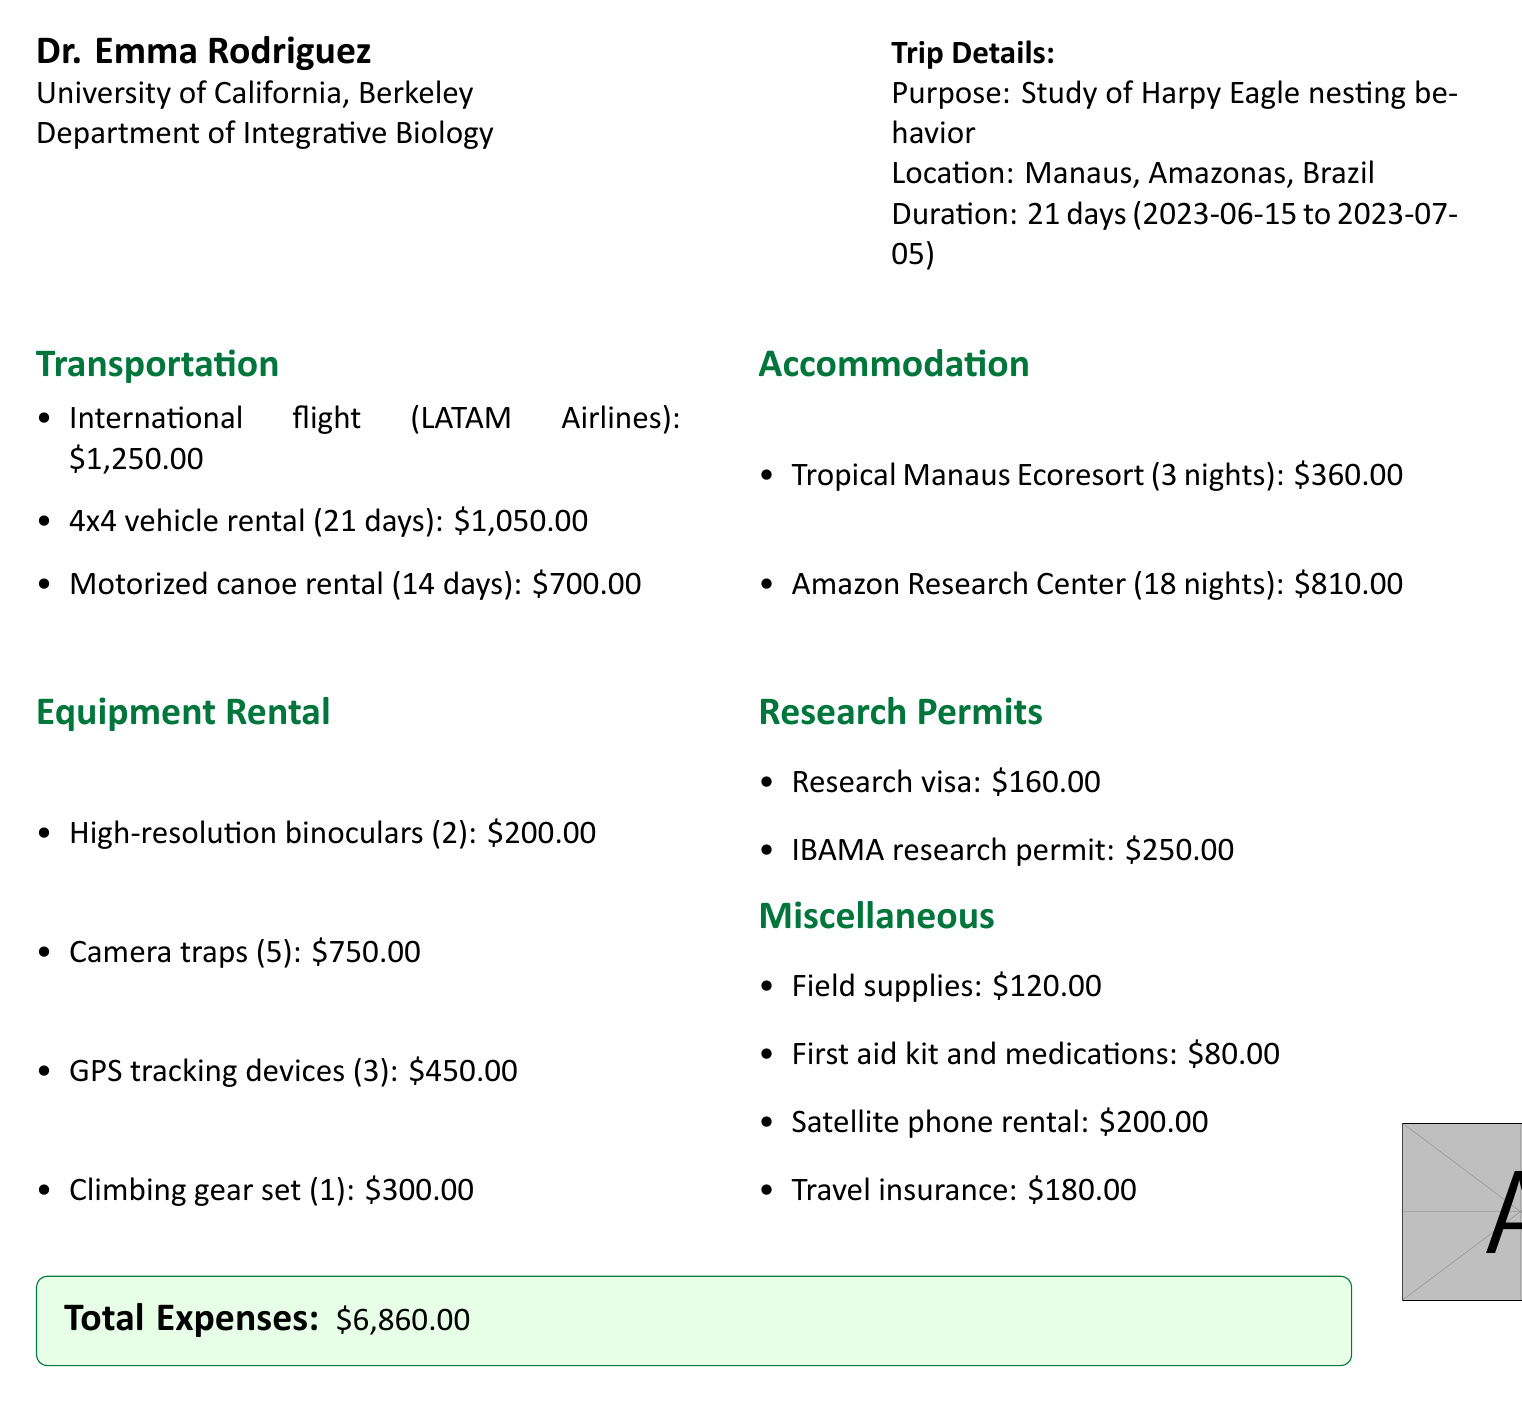What is the purpose of the trip? The purpose of the trip is stated in the document as "Study of Harpy Eagle (Harpia harpyja) nesting behavior."
Answer: Study of Harpy Eagle (Harpia harpyja) nesting behavior Who is the researcher? The document specifies the researcher's name as "Dr. Emma Rodriguez."
Answer: Dr. Emma Rodriguez What is the total cost of accommodation? The total accommodation costs are the sum of the hotel and field station expenses, which are $360.00 + $810.00 = $1,170.00.
Answer: $1,170.00 How many nights did the researcher stay at the Amazon Research Center? The document states that the researcher stayed at the Amazon Research Center for "18 nights."
Answer: 18 nights What type of vehicle was rented for local transportation? The document describes the local transportation as a "4x4 vehicle rental."
Answer: 4x4 vehicle rental What is the cost of the research visa? The cost of the research visa is specifically stated as "$160.00."
Answer: $160.00 How many pieces of climbing gear were rented? The document indicates that 1 climbing gear set was rented.
Answer: 1 What is the duration of the entire trip? The duration of the trip is clearly stated as "21 days."
Answer: 21 days What is the name of the hotel where the researcher stayed? The document identifies the hotel as "Tropical Manaus Ecoresort."
Answer: Tropical Manaus Ecoresort 